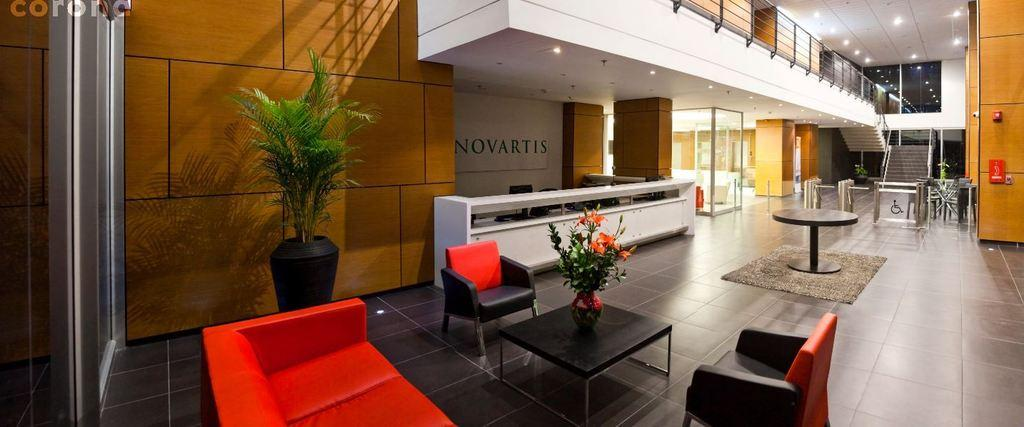What type of furniture is present in the image? There is a couch, a table, and a chair in the image. Where are these furniture items located? The couch, table, and chair are on the floor. What else can be seen in the image besides furniture? There is a flower pot in the image. What can be seen in the background of the image? There are stairs and a glass door in the background of the image. What type of scarf is draped over the couch in the image? There is no scarf present in the image; it only features a couch, table, chair, flower pot, stairs, and a glass door. 